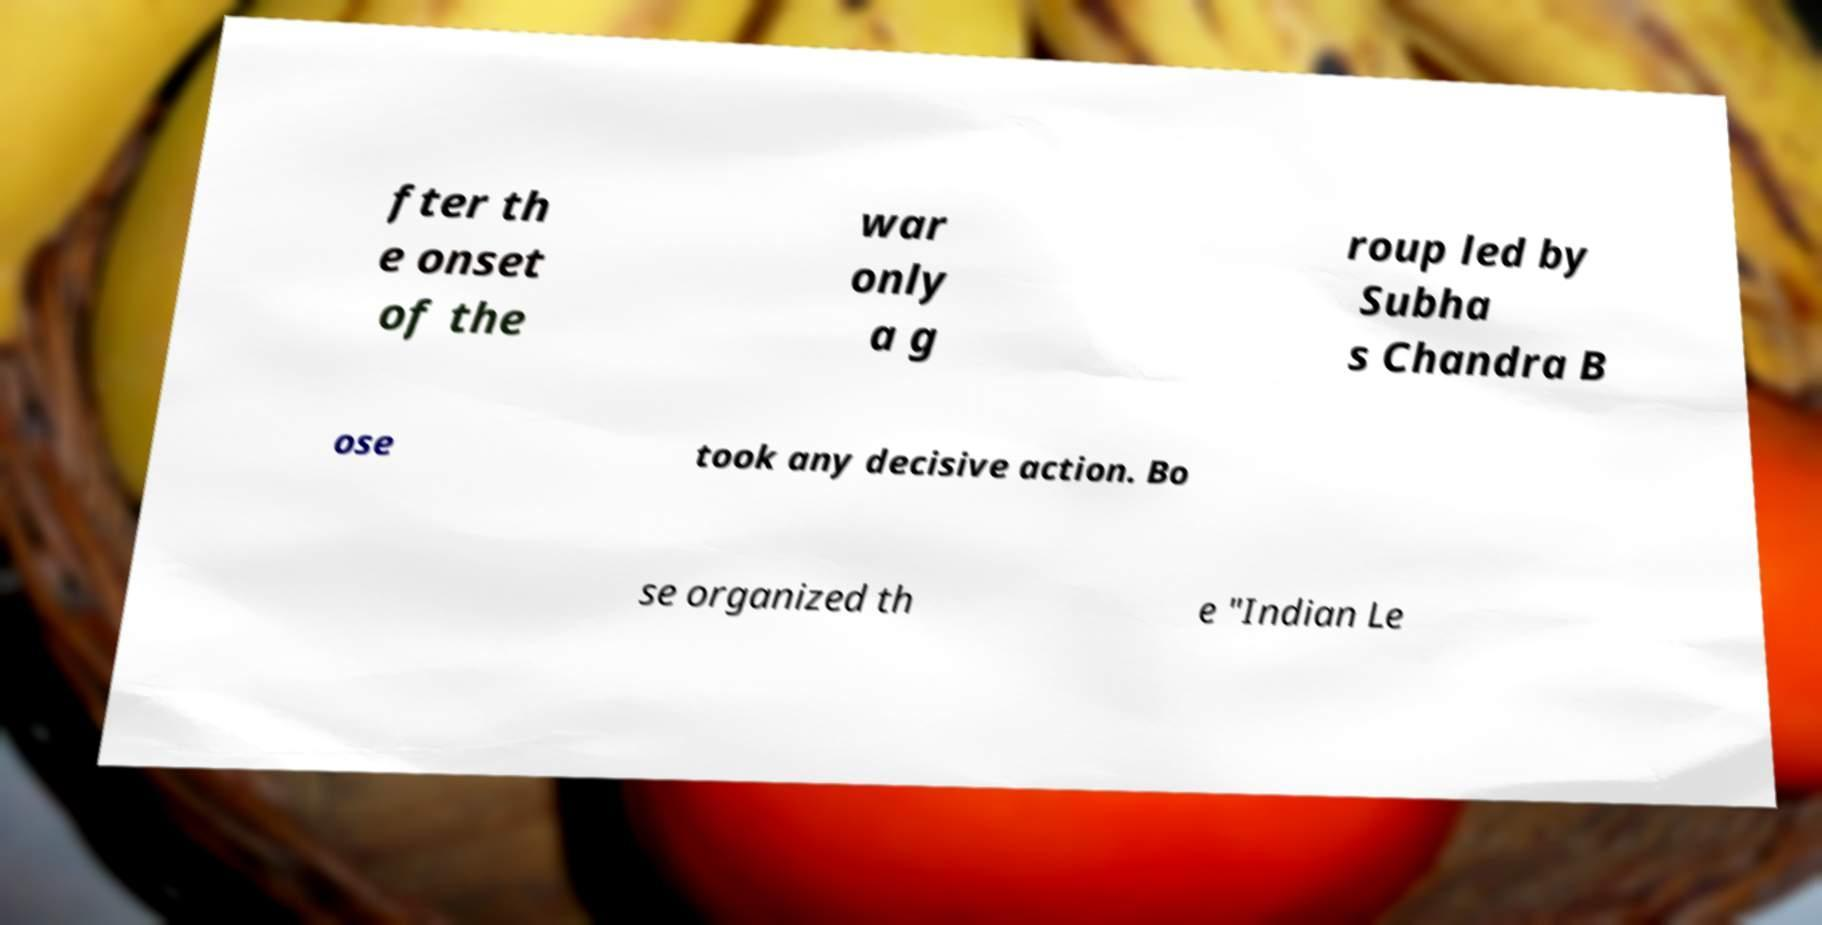Could you assist in decoding the text presented in this image and type it out clearly? fter th e onset of the war only a g roup led by Subha s Chandra B ose took any decisive action. Bo se organized th e "Indian Le 